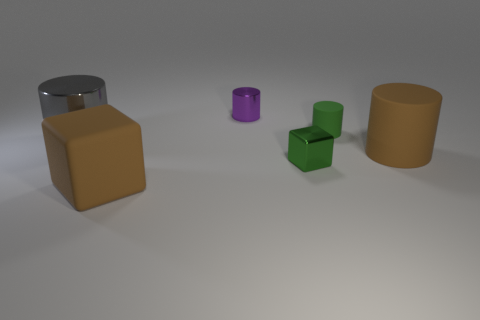Are there any other things that are the same size as the brown matte cylinder?
Offer a terse response. Yes. Is the shape of the metallic object left of the purple metal cylinder the same as the large matte object behind the green block?
Make the answer very short. Yes. Are there fewer small green blocks that are on the left side of the small green cylinder than brown matte things behind the small metallic cylinder?
Keep it short and to the point. No. How many other objects are the same shape as the tiny green shiny thing?
Offer a very short reply. 1. The large gray thing that is made of the same material as the small purple cylinder is what shape?
Your response must be concise. Cylinder. There is a metallic object that is both on the right side of the big gray cylinder and behind the metal block; what is its color?
Your response must be concise. Purple. Is the cube that is behind the large brown rubber block made of the same material as the brown cube?
Your answer should be compact. No. Is the number of big things behind the small matte cylinder less than the number of large gray metal objects?
Your response must be concise. Yes. Are there any large brown cylinders that have the same material as the large gray cylinder?
Make the answer very short. No. Do the brown rubber cube and the shiny object that is left of the small metal cylinder have the same size?
Ensure brevity in your answer.  Yes. 